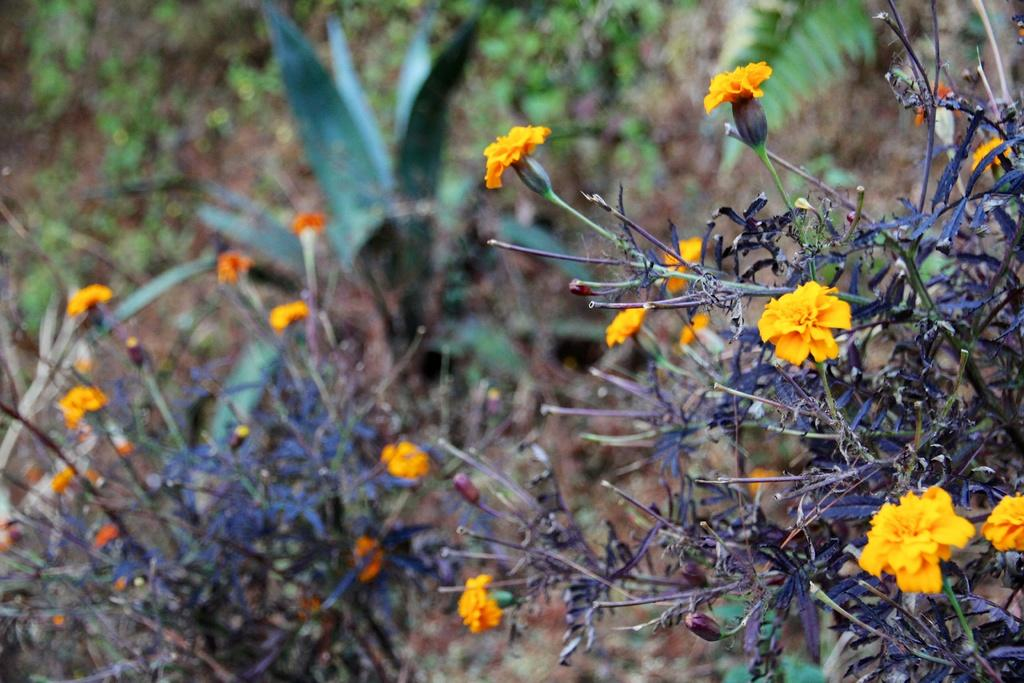What type of plants can be seen in the image? There are plants with flowers in the image. What can be seen in the background of the image? There are trees in the background of the image. Can you tell me how many times the person jumped in the image? There is no person present in the image, so it is not possible to determine how many times they jumped. 